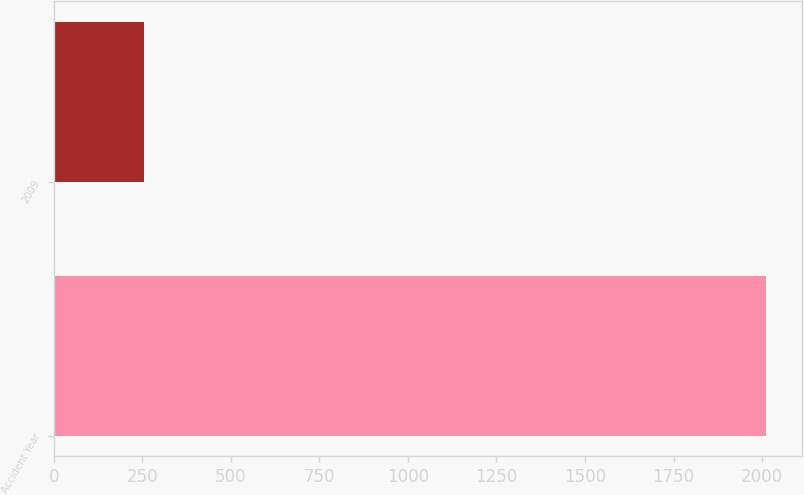Convert chart. <chart><loc_0><loc_0><loc_500><loc_500><bar_chart><fcel>Accident Year<fcel>2009<nl><fcel>2012<fcel>256<nl></chart> 